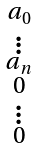<formula> <loc_0><loc_0><loc_500><loc_500>\begin{smallmatrix} a _ { 0 } \\ \vdots \\ a _ { n } \\ 0 \\ \vdots \\ 0 \end{smallmatrix}</formula> 